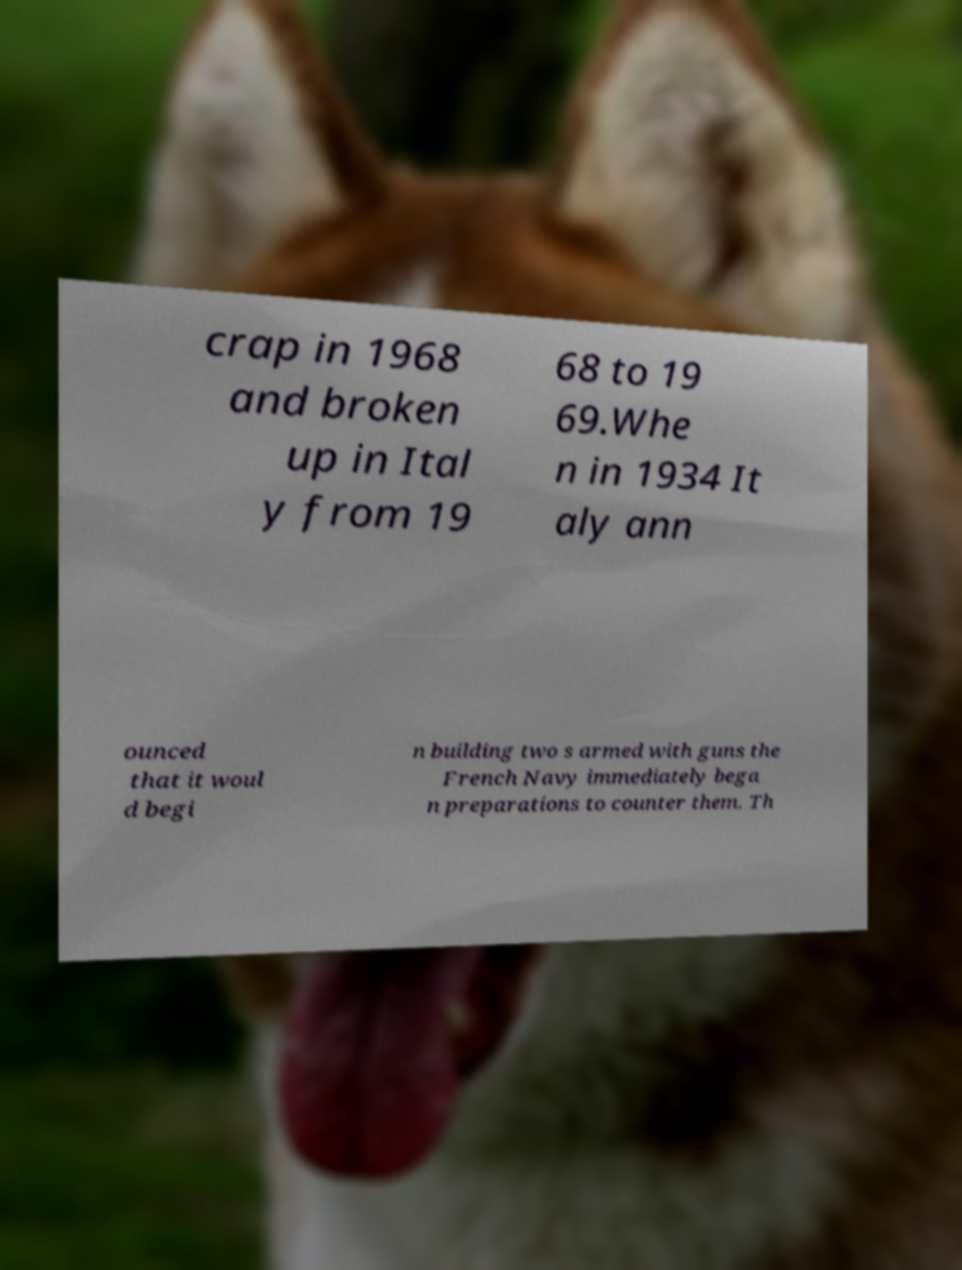There's text embedded in this image that I need extracted. Can you transcribe it verbatim? crap in 1968 and broken up in Ital y from 19 68 to 19 69.Whe n in 1934 It aly ann ounced that it woul d begi n building two s armed with guns the French Navy immediately bega n preparations to counter them. Th 